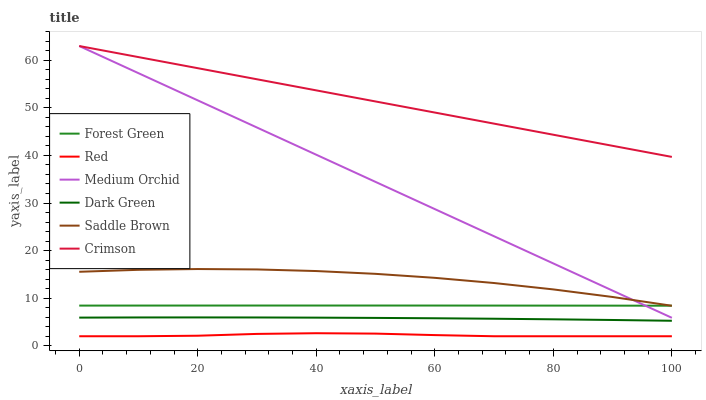Does Red have the minimum area under the curve?
Answer yes or no. Yes. Does Crimson have the maximum area under the curve?
Answer yes or no. Yes. Does Forest Green have the minimum area under the curve?
Answer yes or no. No. Does Forest Green have the maximum area under the curve?
Answer yes or no. No. Is Medium Orchid the smoothest?
Answer yes or no. Yes. Is Saddle Brown the roughest?
Answer yes or no. Yes. Is Forest Green the smoothest?
Answer yes or no. No. Is Forest Green the roughest?
Answer yes or no. No. Does Red have the lowest value?
Answer yes or no. Yes. Does Forest Green have the lowest value?
Answer yes or no. No. Does Crimson have the highest value?
Answer yes or no. Yes. Does Forest Green have the highest value?
Answer yes or no. No. Is Red less than Dark Green?
Answer yes or no. Yes. Is Forest Green greater than Red?
Answer yes or no. Yes. Does Medium Orchid intersect Crimson?
Answer yes or no. Yes. Is Medium Orchid less than Crimson?
Answer yes or no. No. Is Medium Orchid greater than Crimson?
Answer yes or no. No. Does Red intersect Dark Green?
Answer yes or no. No. 